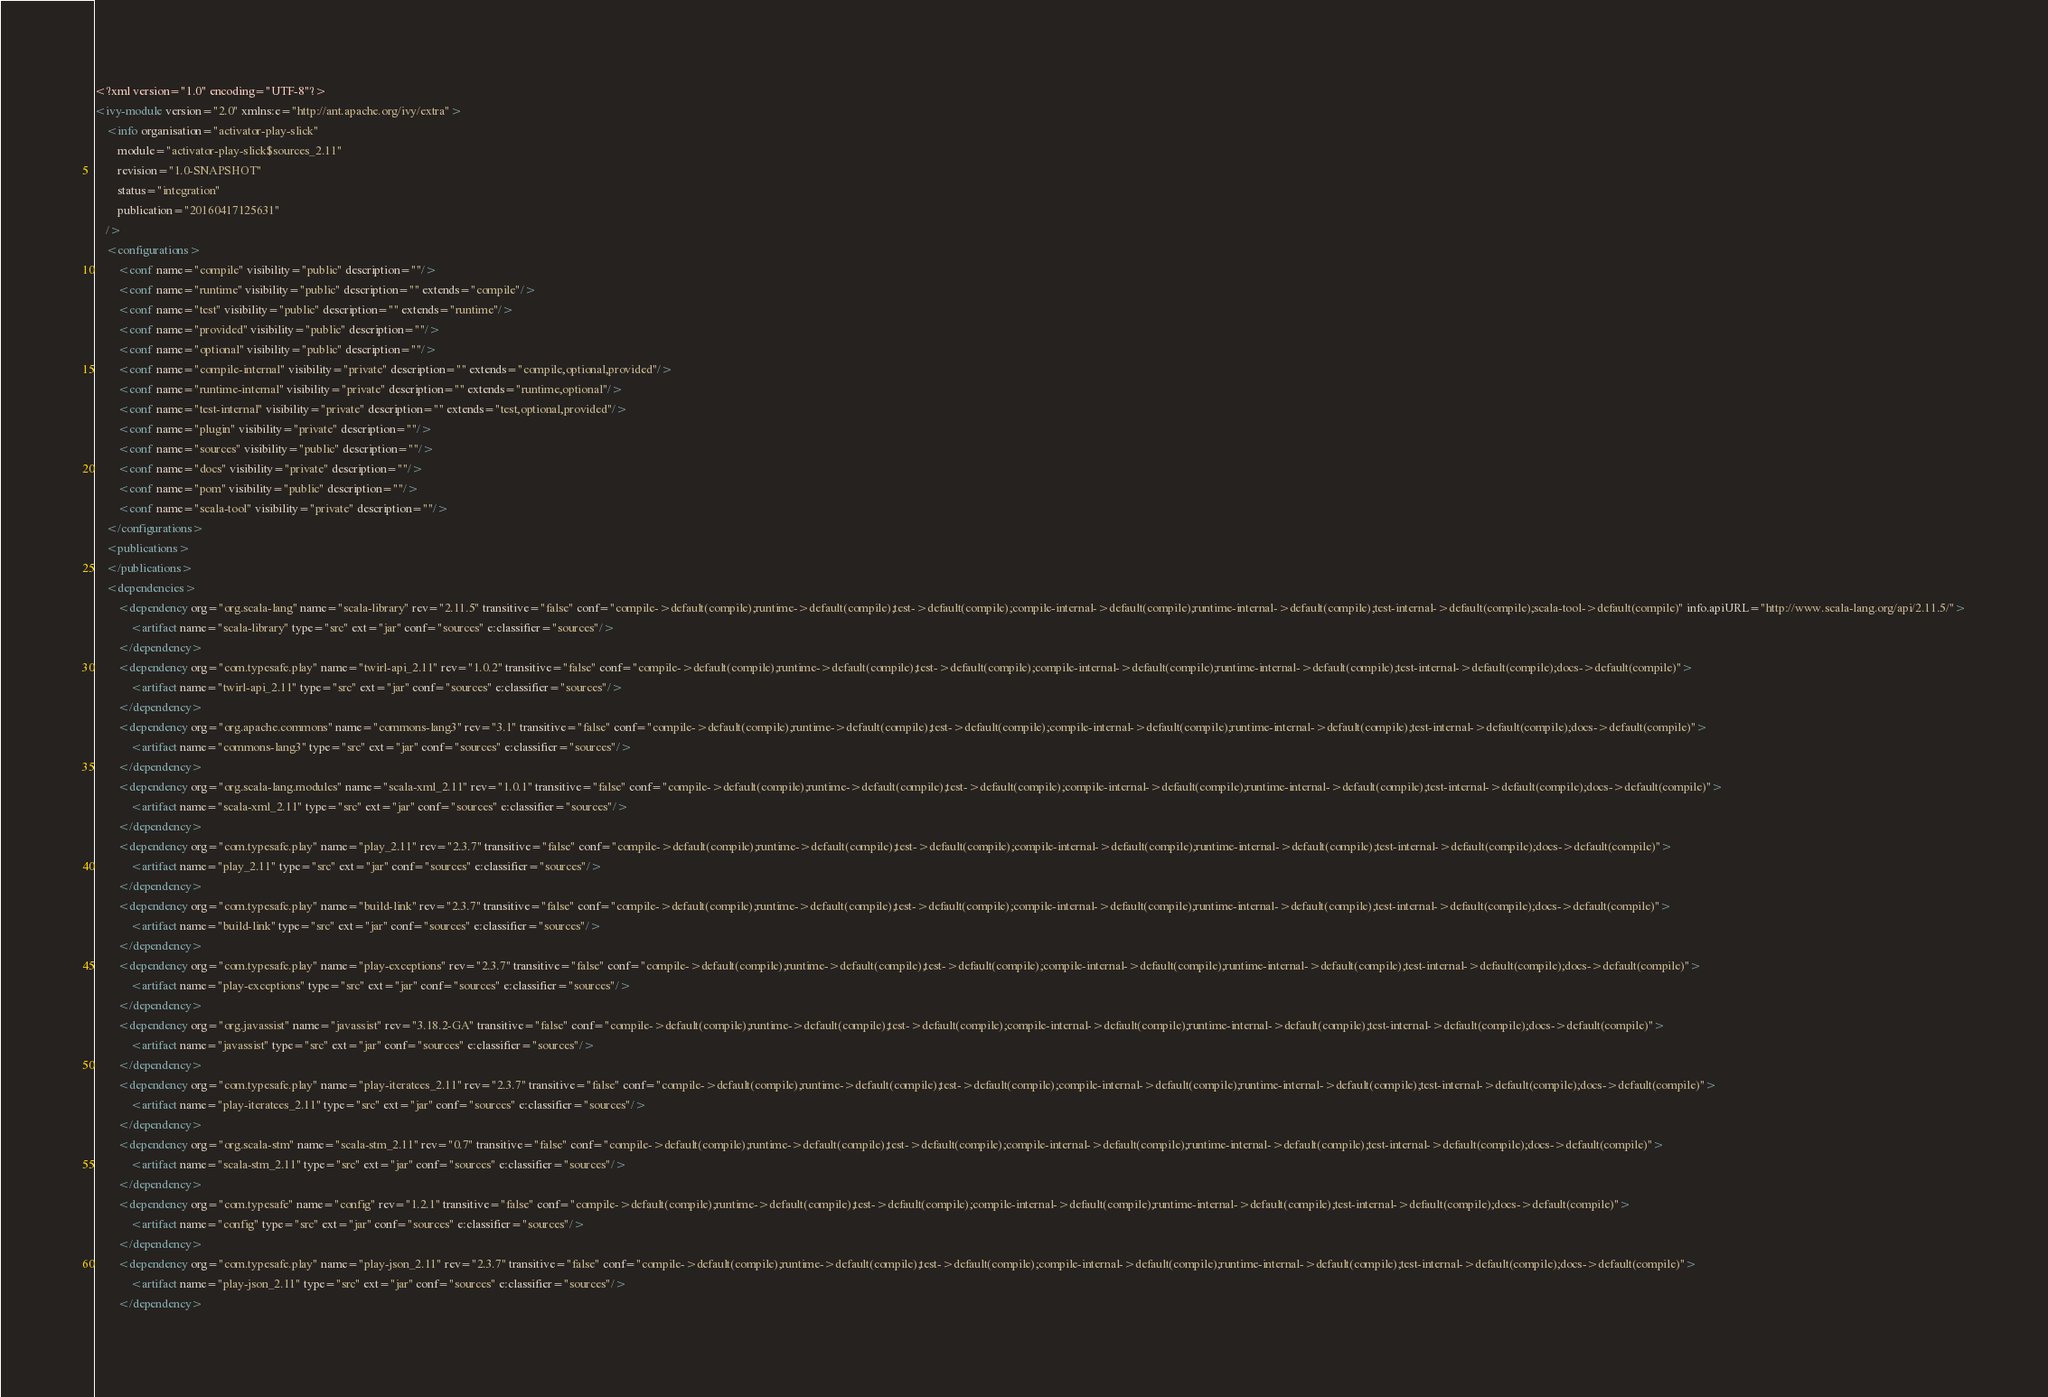Convert code to text. <code><loc_0><loc_0><loc_500><loc_500><_XML_><?xml version="1.0" encoding="UTF-8"?>
<ivy-module version="2.0" xmlns:e="http://ant.apache.org/ivy/extra">
	<info organisation="activator-play-slick"
		module="activator-play-slick$sources_2.11"
		revision="1.0-SNAPSHOT"
		status="integration"
		publication="20160417125631"
	/>
	<configurations>
		<conf name="compile" visibility="public" description=""/>
		<conf name="runtime" visibility="public" description="" extends="compile"/>
		<conf name="test" visibility="public" description="" extends="runtime"/>
		<conf name="provided" visibility="public" description=""/>
		<conf name="optional" visibility="public" description=""/>
		<conf name="compile-internal" visibility="private" description="" extends="compile,optional,provided"/>
		<conf name="runtime-internal" visibility="private" description="" extends="runtime,optional"/>
		<conf name="test-internal" visibility="private" description="" extends="test,optional,provided"/>
		<conf name="plugin" visibility="private" description=""/>
		<conf name="sources" visibility="public" description=""/>
		<conf name="docs" visibility="private" description=""/>
		<conf name="pom" visibility="public" description=""/>
		<conf name="scala-tool" visibility="private" description=""/>
	</configurations>
	<publications>
	</publications>
	<dependencies>
		<dependency org="org.scala-lang" name="scala-library" rev="2.11.5" transitive="false" conf="compile->default(compile);runtime->default(compile);test->default(compile);compile-internal->default(compile);runtime-internal->default(compile);test-internal->default(compile);scala-tool->default(compile)" info.apiURL="http://www.scala-lang.org/api/2.11.5/">
			<artifact name="scala-library" type="src" ext="jar" conf="sources" e:classifier="sources"/>
		</dependency>
		<dependency org="com.typesafe.play" name="twirl-api_2.11" rev="1.0.2" transitive="false" conf="compile->default(compile);runtime->default(compile);test->default(compile);compile-internal->default(compile);runtime-internal->default(compile);test-internal->default(compile);docs->default(compile)">
			<artifact name="twirl-api_2.11" type="src" ext="jar" conf="sources" e:classifier="sources"/>
		</dependency>
		<dependency org="org.apache.commons" name="commons-lang3" rev="3.1" transitive="false" conf="compile->default(compile);runtime->default(compile);test->default(compile);compile-internal->default(compile);runtime-internal->default(compile);test-internal->default(compile);docs->default(compile)">
			<artifact name="commons-lang3" type="src" ext="jar" conf="sources" e:classifier="sources"/>
		</dependency>
		<dependency org="org.scala-lang.modules" name="scala-xml_2.11" rev="1.0.1" transitive="false" conf="compile->default(compile);runtime->default(compile);test->default(compile);compile-internal->default(compile);runtime-internal->default(compile);test-internal->default(compile);docs->default(compile)">
			<artifact name="scala-xml_2.11" type="src" ext="jar" conf="sources" e:classifier="sources"/>
		</dependency>
		<dependency org="com.typesafe.play" name="play_2.11" rev="2.3.7" transitive="false" conf="compile->default(compile);runtime->default(compile);test->default(compile);compile-internal->default(compile);runtime-internal->default(compile);test-internal->default(compile);docs->default(compile)">
			<artifact name="play_2.11" type="src" ext="jar" conf="sources" e:classifier="sources"/>
		</dependency>
		<dependency org="com.typesafe.play" name="build-link" rev="2.3.7" transitive="false" conf="compile->default(compile);runtime->default(compile);test->default(compile);compile-internal->default(compile);runtime-internal->default(compile);test-internal->default(compile);docs->default(compile)">
			<artifact name="build-link" type="src" ext="jar" conf="sources" e:classifier="sources"/>
		</dependency>
		<dependency org="com.typesafe.play" name="play-exceptions" rev="2.3.7" transitive="false" conf="compile->default(compile);runtime->default(compile);test->default(compile);compile-internal->default(compile);runtime-internal->default(compile);test-internal->default(compile);docs->default(compile)">
			<artifact name="play-exceptions" type="src" ext="jar" conf="sources" e:classifier="sources"/>
		</dependency>
		<dependency org="org.javassist" name="javassist" rev="3.18.2-GA" transitive="false" conf="compile->default(compile);runtime->default(compile);test->default(compile);compile-internal->default(compile);runtime-internal->default(compile);test-internal->default(compile);docs->default(compile)">
			<artifact name="javassist" type="src" ext="jar" conf="sources" e:classifier="sources"/>
		</dependency>
		<dependency org="com.typesafe.play" name="play-iteratees_2.11" rev="2.3.7" transitive="false" conf="compile->default(compile);runtime->default(compile);test->default(compile);compile-internal->default(compile);runtime-internal->default(compile);test-internal->default(compile);docs->default(compile)">
			<artifact name="play-iteratees_2.11" type="src" ext="jar" conf="sources" e:classifier="sources"/>
		</dependency>
		<dependency org="org.scala-stm" name="scala-stm_2.11" rev="0.7" transitive="false" conf="compile->default(compile);runtime->default(compile);test->default(compile);compile-internal->default(compile);runtime-internal->default(compile);test-internal->default(compile);docs->default(compile)">
			<artifact name="scala-stm_2.11" type="src" ext="jar" conf="sources" e:classifier="sources"/>
		</dependency>
		<dependency org="com.typesafe" name="config" rev="1.2.1" transitive="false" conf="compile->default(compile);runtime->default(compile);test->default(compile);compile-internal->default(compile);runtime-internal->default(compile);test-internal->default(compile);docs->default(compile)">
			<artifact name="config" type="src" ext="jar" conf="sources" e:classifier="sources"/>
		</dependency>
		<dependency org="com.typesafe.play" name="play-json_2.11" rev="2.3.7" transitive="false" conf="compile->default(compile);runtime->default(compile);test->default(compile);compile-internal->default(compile);runtime-internal->default(compile);test-internal->default(compile);docs->default(compile)">
			<artifact name="play-json_2.11" type="src" ext="jar" conf="sources" e:classifier="sources"/>
		</dependency></code> 